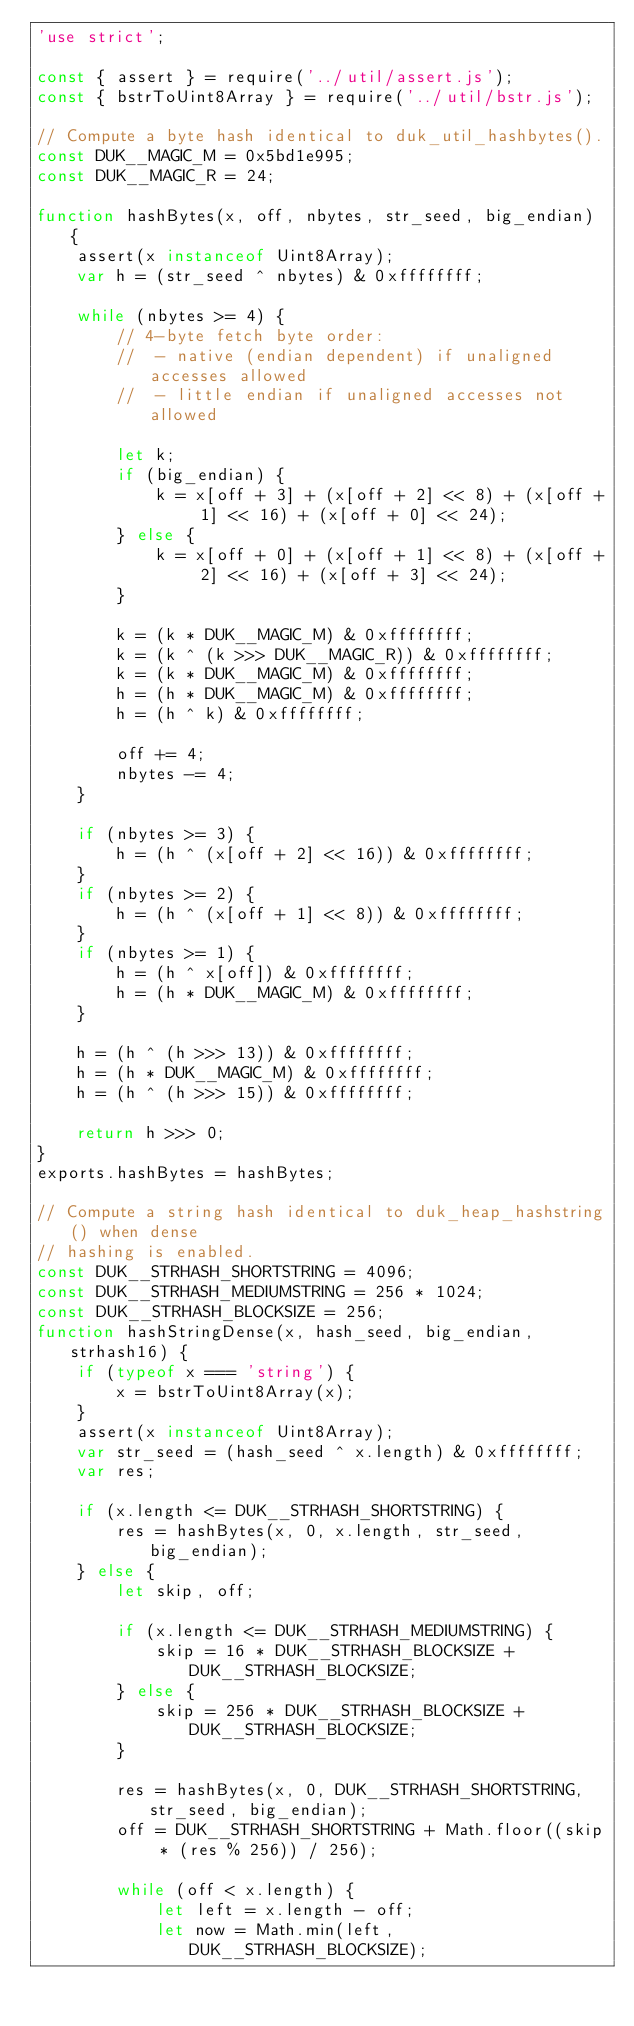Convert code to text. <code><loc_0><loc_0><loc_500><loc_500><_JavaScript_>'use strict';

const { assert } = require('../util/assert.js');
const { bstrToUint8Array } = require('../util/bstr.js');

// Compute a byte hash identical to duk_util_hashbytes().
const DUK__MAGIC_M = 0x5bd1e995;
const DUK__MAGIC_R = 24;

function hashBytes(x, off, nbytes, str_seed, big_endian) {
    assert(x instanceof Uint8Array);
    var h = (str_seed ^ nbytes) & 0xffffffff;

    while (nbytes >= 4) {
        // 4-byte fetch byte order:
        //  - native (endian dependent) if unaligned accesses allowed
        //  - little endian if unaligned accesses not allowed

        let k;
        if (big_endian) {
            k = x[off + 3] + (x[off + 2] << 8) + (x[off + 1] << 16) + (x[off + 0] << 24);
        } else {
            k = x[off + 0] + (x[off + 1] << 8) + (x[off + 2] << 16) + (x[off + 3] << 24);
        }

        k = (k * DUK__MAGIC_M) & 0xffffffff;
        k = (k ^ (k >>> DUK__MAGIC_R)) & 0xffffffff;
        k = (k * DUK__MAGIC_M) & 0xffffffff;
        h = (h * DUK__MAGIC_M) & 0xffffffff;
        h = (h ^ k) & 0xffffffff;

        off += 4;
        nbytes -= 4;
    }

    if (nbytes >= 3) {
        h = (h ^ (x[off + 2] << 16)) & 0xffffffff;
    }
    if (nbytes >= 2) {
        h = (h ^ (x[off + 1] << 8)) & 0xffffffff;
    }
    if (nbytes >= 1) {
        h = (h ^ x[off]) & 0xffffffff;
        h = (h * DUK__MAGIC_M) & 0xffffffff;
    }

    h = (h ^ (h >>> 13)) & 0xffffffff;
    h = (h * DUK__MAGIC_M) & 0xffffffff;
    h = (h ^ (h >>> 15)) & 0xffffffff;

    return h >>> 0;
}
exports.hashBytes = hashBytes;

// Compute a string hash identical to duk_heap_hashstring() when dense
// hashing is enabled.
const DUK__STRHASH_SHORTSTRING = 4096;
const DUK__STRHASH_MEDIUMSTRING = 256 * 1024;
const DUK__STRHASH_BLOCKSIZE = 256;
function hashStringDense(x, hash_seed, big_endian, strhash16) {
    if (typeof x === 'string') {
        x = bstrToUint8Array(x);
    }
    assert(x instanceof Uint8Array);
    var str_seed = (hash_seed ^ x.length) & 0xffffffff;
    var res;

    if (x.length <= DUK__STRHASH_SHORTSTRING) {
        res = hashBytes(x, 0, x.length, str_seed, big_endian);
    } else {
        let skip, off;

        if (x.length <= DUK__STRHASH_MEDIUMSTRING) {
            skip = 16 * DUK__STRHASH_BLOCKSIZE + DUK__STRHASH_BLOCKSIZE;
        } else {
            skip = 256 * DUK__STRHASH_BLOCKSIZE + DUK__STRHASH_BLOCKSIZE;
        }

        res = hashBytes(x, 0, DUK__STRHASH_SHORTSTRING, str_seed, big_endian);
        off = DUK__STRHASH_SHORTSTRING + Math.floor((skip * (res % 256)) / 256);

        while (off < x.length) {
            let left = x.length - off;
            let now = Math.min(left, DUK__STRHASH_BLOCKSIZE);</code> 